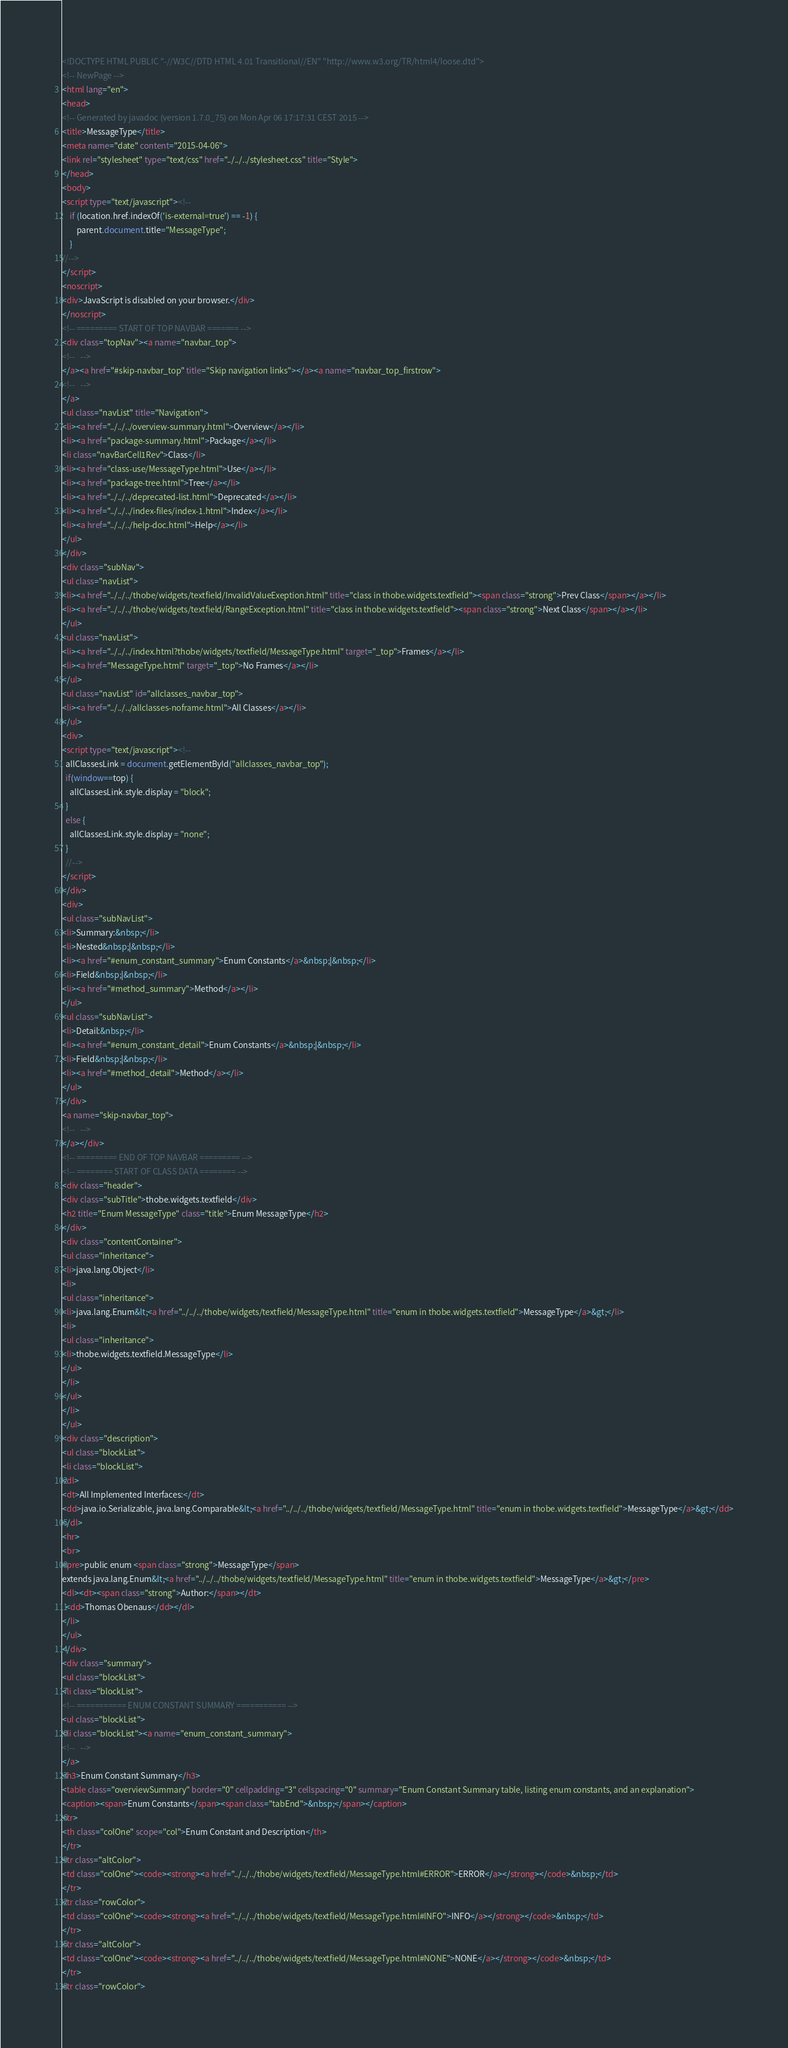Convert code to text. <code><loc_0><loc_0><loc_500><loc_500><_HTML_><!DOCTYPE HTML PUBLIC "-//W3C//DTD HTML 4.01 Transitional//EN" "http://www.w3.org/TR/html4/loose.dtd">
<!-- NewPage -->
<html lang="en">
<head>
<!-- Generated by javadoc (version 1.7.0_75) on Mon Apr 06 17:17:31 CEST 2015 -->
<title>MessageType</title>
<meta name="date" content="2015-04-06">
<link rel="stylesheet" type="text/css" href="../../../stylesheet.css" title="Style">
</head>
<body>
<script type="text/javascript"><!--
    if (location.href.indexOf('is-external=true') == -1) {
        parent.document.title="MessageType";
    }
//-->
</script>
<noscript>
<div>JavaScript is disabled on your browser.</div>
</noscript>
<!-- ========= START OF TOP NAVBAR ======= -->
<div class="topNav"><a name="navbar_top">
<!--   -->
</a><a href="#skip-navbar_top" title="Skip navigation links"></a><a name="navbar_top_firstrow">
<!--   -->
</a>
<ul class="navList" title="Navigation">
<li><a href="../../../overview-summary.html">Overview</a></li>
<li><a href="package-summary.html">Package</a></li>
<li class="navBarCell1Rev">Class</li>
<li><a href="class-use/MessageType.html">Use</a></li>
<li><a href="package-tree.html">Tree</a></li>
<li><a href="../../../deprecated-list.html">Deprecated</a></li>
<li><a href="../../../index-files/index-1.html">Index</a></li>
<li><a href="../../../help-doc.html">Help</a></li>
</ul>
</div>
<div class="subNav">
<ul class="navList">
<li><a href="../../../thobe/widgets/textfield/InvalidValueExeption.html" title="class in thobe.widgets.textfield"><span class="strong">Prev Class</span></a></li>
<li><a href="../../../thobe/widgets/textfield/RangeException.html" title="class in thobe.widgets.textfield"><span class="strong">Next Class</span></a></li>
</ul>
<ul class="navList">
<li><a href="../../../index.html?thobe/widgets/textfield/MessageType.html" target="_top">Frames</a></li>
<li><a href="MessageType.html" target="_top">No Frames</a></li>
</ul>
<ul class="navList" id="allclasses_navbar_top">
<li><a href="../../../allclasses-noframe.html">All Classes</a></li>
</ul>
<div>
<script type="text/javascript"><!--
  allClassesLink = document.getElementById("allclasses_navbar_top");
  if(window==top) {
    allClassesLink.style.display = "block";
  }
  else {
    allClassesLink.style.display = "none";
  }
  //-->
</script>
</div>
<div>
<ul class="subNavList">
<li>Summary:&nbsp;</li>
<li>Nested&nbsp;|&nbsp;</li>
<li><a href="#enum_constant_summary">Enum Constants</a>&nbsp;|&nbsp;</li>
<li>Field&nbsp;|&nbsp;</li>
<li><a href="#method_summary">Method</a></li>
</ul>
<ul class="subNavList">
<li>Detail:&nbsp;</li>
<li><a href="#enum_constant_detail">Enum Constants</a>&nbsp;|&nbsp;</li>
<li>Field&nbsp;|&nbsp;</li>
<li><a href="#method_detail">Method</a></li>
</ul>
</div>
<a name="skip-navbar_top">
<!--   -->
</a></div>
<!-- ========= END OF TOP NAVBAR ========= -->
<!-- ======== START OF CLASS DATA ======== -->
<div class="header">
<div class="subTitle">thobe.widgets.textfield</div>
<h2 title="Enum MessageType" class="title">Enum MessageType</h2>
</div>
<div class="contentContainer">
<ul class="inheritance">
<li>java.lang.Object</li>
<li>
<ul class="inheritance">
<li>java.lang.Enum&lt;<a href="../../../thobe/widgets/textfield/MessageType.html" title="enum in thobe.widgets.textfield">MessageType</a>&gt;</li>
<li>
<ul class="inheritance">
<li>thobe.widgets.textfield.MessageType</li>
</ul>
</li>
</ul>
</li>
</ul>
<div class="description">
<ul class="blockList">
<li class="blockList">
<dl>
<dt>All Implemented Interfaces:</dt>
<dd>java.io.Serializable, java.lang.Comparable&lt;<a href="../../../thobe/widgets/textfield/MessageType.html" title="enum in thobe.widgets.textfield">MessageType</a>&gt;</dd>
</dl>
<hr>
<br>
<pre>public enum <span class="strong">MessageType</span>
extends java.lang.Enum&lt;<a href="../../../thobe/widgets/textfield/MessageType.html" title="enum in thobe.widgets.textfield">MessageType</a>&gt;</pre>
<dl><dt><span class="strong">Author:</span></dt>
  <dd>Thomas Obenaus</dd></dl>
</li>
</ul>
</div>
<div class="summary">
<ul class="blockList">
<li class="blockList">
<!-- =========== ENUM CONSTANT SUMMARY =========== -->
<ul class="blockList">
<li class="blockList"><a name="enum_constant_summary">
<!--   -->
</a>
<h3>Enum Constant Summary</h3>
<table class="overviewSummary" border="0" cellpadding="3" cellspacing="0" summary="Enum Constant Summary table, listing enum constants, and an explanation">
<caption><span>Enum Constants</span><span class="tabEnd">&nbsp;</span></caption>
<tr>
<th class="colOne" scope="col">Enum Constant and Description</th>
</tr>
<tr class="altColor">
<td class="colOne"><code><strong><a href="../../../thobe/widgets/textfield/MessageType.html#ERROR">ERROR</a></strong></code>&nbsp;</td>
</tr>
<tr class="rowColor">
<td class="colOne"><code><strong><a href="../../../thobe/widgets/textfield/MessageType.html#INFO">INFO</a></strong></code>&nbsp;</td>
</tr>
<tr class="altColor">
<td class="colOne"><code><strong><a href="../../../thobe/widgets/textfield/MessageType.html#NONE">NONE</a></strong></code>&nbsp;</td>
</tr>
<tr class="rowColor"></code> 